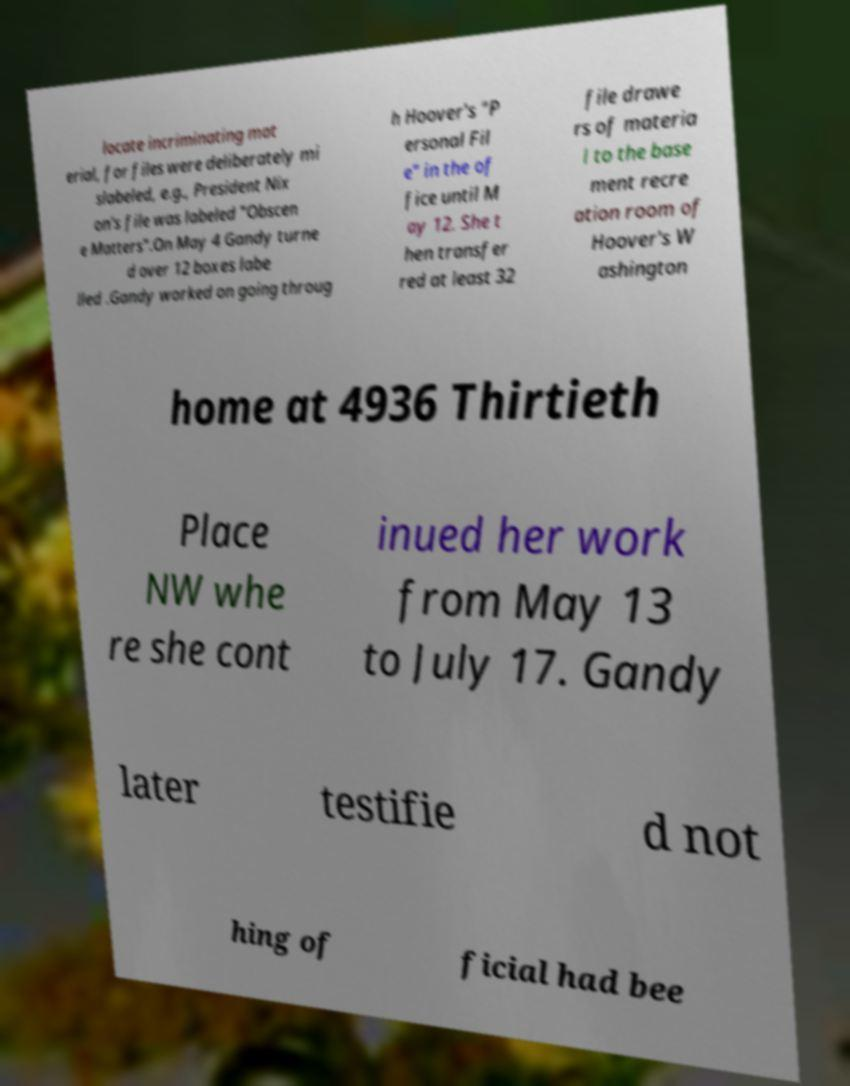I need the written content from this picture converted into text. Can you do that? locate incriminating mat erial, for files were deliberately mi slabeled, e.g., President Nix on's file was labeled "Obscen e Matters".On May 4 Gandy turne d over 12 boxes labe lled .Gandy worked on going throug h Hoover's "P ersonal Fil e" in the of fice until M ay 12. She t hen transfer red at least 32 file drawe rs of materia l to the base ment recre ation room of Hoover's W ashington home at 4936 Thirtieth Place NW whe re she cont inued her work from May 13 to July 17. Gandy later testifie d not hing of ficial had bee 